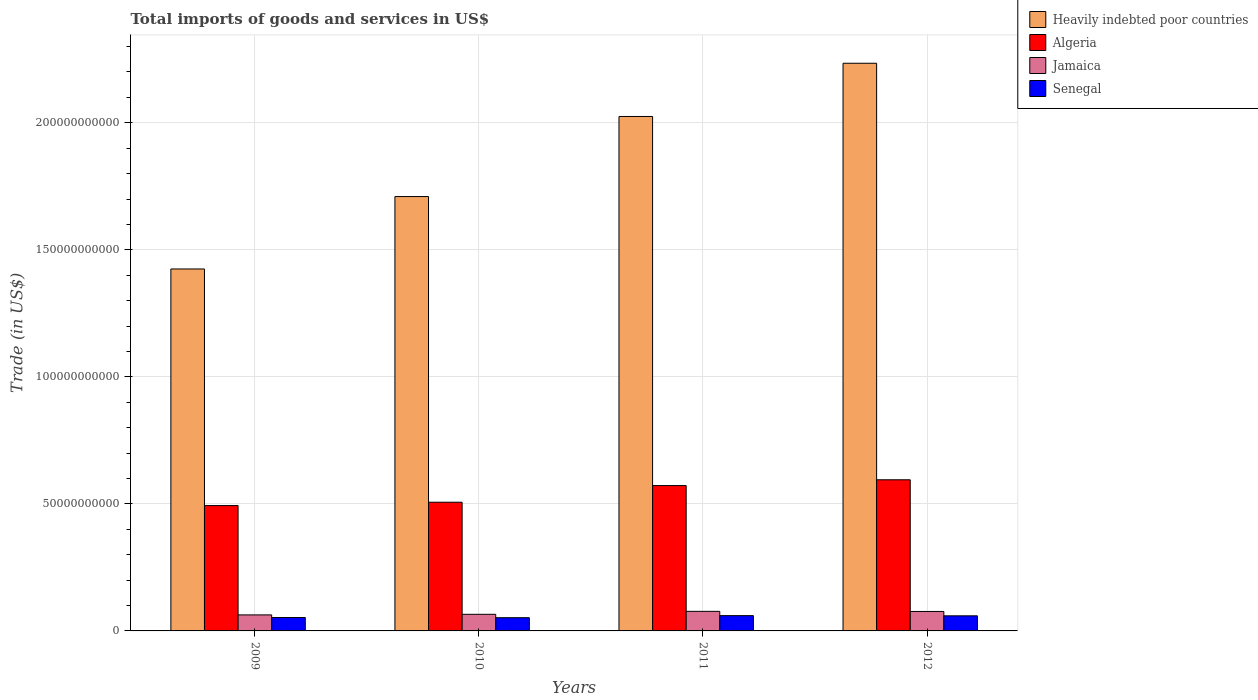How many different coloured bars are there?
Provide a succinct answer. 4. How many groups of bars are there?
Give a very brief answer. 4. Are the number of bars on each tick of the X-axis equal?
Ensure brevity in your answer.  Yes. How many bars are there on the 2nd tick from the right?
Provide a succinct answer. 4. What is the total imports of goods and services in Algeria in 2010?
Keep it short and to the point. 5.07e+1. Across all years, what is the maximum total imports of goods and services in Algeria?
Your response must be concise. 5.95e+1. Across all years, what is the minimum total imports of goods and services in Senegal?
Offer a terse response. 5.20e+09. In which year was the total imports of goods and services in Heavily indebted poor countries minimum?
Provide a short and direct response. 2009. What is the total total imports of goods and services in Jamaica in the graph?
Your answer should be very brief. 2.82e+1. What is the difference between the total imports of goods and services in Heavily indebted poor countries in 2009 and that in 2012?
Ensure brevity in your answer.  -8.10e+1. What is the difference between the total imports of goods and services in Heavily indebted poor countries in 2010 and the total imports of goods and services in Senegal in 2009?
Give a very brief answer. 1.66e+11. What is the average total imports of goods and services in Heavily indebted poor countries per year?
Provide a short and direct response. 1.85e+11. In the year 2010, what is the difference between the total imports of goods and services in Senegal and total imports of goods and services in Heavily indebted poor countries?
Keep it short and to the point. -1.66e+11. What is the ratio of the total imports of goods and services in Algeria in 2009 to that in 2010?
Provide a short and direct response. 0.97. Is the difference between the total imports of goods and services in Senegal in 2009 and 2012 greater than the difference between the total imports of goods and services in Heavily indebted poor countries in 2009 and 2012?
Keep it short and to the point. Yes. What is the difference between the highest and the second highest total imports of goods and services in Jamaica?
Provide a short and direct response. 4.67e+07. What is the difference between the highest and the lowest total imports of goods and services in Jamaica?
Offer a very short reply. 1.40e+09. In how many years, is the total imports of goods and services in Senegal greater than the average total imports of goods and services in Senegal taken over all years?
Your response must be concise. 2. Is the sum of the total imports of goods and services in Algeria in 2011 and 2012 greater than the maximum total imports of goods and services in Heavily indebted poor countries across all years?
Give a very brief answer. No. What does the 4th bar from the left in 2011 represents?
Your response must be concise. Senegal. What does the 4th bar from the right in 2011 represents?
Offer a very short reply. Heavily indebted poor countries. How many years are there in the graph?
Provide a succinct answer. 4. What is the difference between two consecutive major ticks on the Y-axis?
Make the answer very short. 5.00e+1. Are the values on the major ticks of Y-axis written in scientific E-notation?
Your answer should be very brief. No. What is the title of the graph?
Provide a short and direct response. Total imports of goods and services in US$. What is the label or title of the Y-axis?
Provide a short and direct response. Trade (in US$). What is the Trade (in US$) in Heavily indebted poor countries in 2009?
Keep it short and to the point. 1.42e+11. What is the Trade (in US$) in Algeria in 2009?
Keep it short and to the point. 4.93e+1. What is the Trade (in US$) of Jamaica in 2009?
Ensure brevity in your answer.  6.31e+09. What is the Trade (in US$) in Senegal in 2009?
Make the answer very short. 5.27e+09. What is the Trade (in US$) in Heavily indebted poor countries in 2010?
Provide a succinct answer. 1.71e+11. What is the Trade (in US$) in Algeria in 2010?
Keep it short and to the point. 5.07e+1. What is the Trade (in US$) in Jamaica in 2010?
Offer a very short reply. 6.54e+09. What is the Trade (in US$) in Senegal in 2010?
Give a very brief answer. 5.20e+09. What is the Trade (in US$) of Heavily indebted poor countries in 2011?
Provide a succinct answer. 2.02e+11. What is the Trade (in US$) in Algeria in 2011?
Your response must be concise. 5.72e+1. What is the Trade (in US$) of Jamaica in 2011?
Keep it short and to the point. 7.70e+09. What is the Trade (in US$) of Senegal in 2011?
Give a very brief answer. 6.02e+09. What is the Trade (in US$) in Heavily indebted poor countries in 2012?
Ensure brevity in your answer.  2.23e+11. What is the Trade (in US$) in Algeria in 2012?
Your answer should be very brief. 5.95e+1. What is the Trade (in US$) in Jamaica in 2012?
Make the answer very short. 7.66e+09. What is the Trade (in US$) in Senegal in 2012?
Your answer should be compact. 5.94e+09. Across all years, what is the maximum Trade (in US$) in Heavily indebted poor countries?
Provide a short and direct response. 2.23e+11. Across all years, what is the maximum Trade (in US$) in Algeria?
Provide a short and direct response. 5.95e+1. Across all years, what is the maximum Trade (in US$) of Jamaica?
Provide a short and direct response. 7.70e+09. Across all years, what is the maximum Trade (in US$) in Senegal?
Provide a short and direct response. 6.02e+09. Across all years, what is the minimum Trade (in US$) of Heavily indebted poor countries?
Ensure brevity in your answer.  1.42e+11. Across all years, what is the minimum Trade (in US$) of Algeria?
Provide a short and direct response. 4.93e+1. Across all years, what is the minimum Trade (in US$) of Jamaica?
Your response must be concise. 6.31e+09. Across all years, what is the minimum Trade (in US$) of Senegal?
Offer a terse response. 5.20e+09. What is the total Trade (in US$) of Heavily indebted poor countries in the graph?
Your answer should be compact. 7.39e+11. What is the total Trade (in US$) of Algeria in the graph?
Your answer should be compact. 2.17e+11. What is the total Trade (in US$) of Jamaica in the graph?
Ensure brevity in your answer.  2.82e+1. What is the total Trade (in US$) of Senegal in the graph?
Ensure brevity in your answer.  2.24e+1. What is the difference between the Trade (in US$) of Heavily indebted poor countries in 2009 and that in 2010?
Offer a very short reply. -2.85e+1. What is the difference between the Trade (in US$) in Algeria in 2009 and that in 2010?
Make the answer very short. -1.32e+09. What is the difference between the Trade (in US$) of Jamaica in 2009 and that in 2010?
Provide a succinct answer. -2.33e+08. What is the difference between the Trade (in US$) of Senegal in 2009 and that in 2010?
Ensure brevity in your answer.  6.93e+07. What is the difference between the Trade (in US$) in Heavily indebted poor countries in 2009 and that in 2011?
Your response must be concise. -6.00e+1. What is the difference between the Trade (in US$) of Algeria in 2009 and that in 2011?
Your response must be concise. -7.88e+09. What is the difference between the Trade (in US$) in Jamaica in 2009 and that in 2011?
Keep it short and to the point. -1.40e+09. What is the difference between the Trade (in US$) in Senegal in 2009 and that in 2011?
Keep it short and to the point. -7.46e+08. What is the difference between the Trade (in US$) in Heavily indebted poor countries in 2009 and that in 2012?
Provide a short and direct response. -8.10e+1. What is the difference between the Trade (in US$) of Algeria in 2009 and that in 2012?
Make the answer very short. -1.02e+1. What is the difference between the Trade (in US$) of Jamaica in 2009 and that in 2012?
Ensure brevity in your answer.  -1.35e+09. What is the difference between the Trade (in US$) of Senegal in 2009 and that in 2012?
Keep it short and to the point. -6.71e+08. What is the difference between the Trade (in US$) of Heavily indebted poor countries in 2010 and that in 2011?
Your answer should be compact. -3.15e+1. What is the difference between the Trade (in US$) in Algeria in 2010 and that in 2011?
Provide a succinct answer. -6.56e+09. What is the difference between the Trade (in US$) in Jamaica in 2010 and that in 2011?
Your response must be concise. -1.16e+09. What is the difference between the Trade (in US$) of Senegal in 2010 and that in 2011?
Your response must be concise. -8.15e+08. What is the difference between the Trade (in US$) in Heavily indebted poor countries in 2010 and that in 2012?
Keep it short and to the point. -5.25e+1. What is the difference between the Trade (in US$) in Algeria in 2010 and that in 2012?
Ensure brevity in your answer.  -8.83e+09. What is the difference between the Trade (in US$) in Jamaica in 2010 and that in 2012?
Provide a short and direct response. -1.12e+09. What is the difference between the Trade (in US$) in Senegal in 2010 and that in 2012?
Your answer should be compact. -7.40e+08. What is the difference between the Trade (in US$) of Heavily indebted poor countries in 2011 and that in 2012?
Provide a short and direct response. -2.09e+1. What is the difference between the Trade (in US$) in Algeria in 2011 and that in 2012?
Provide a succinct answer. -2.27e+09. What is the difference between the Trade (in US$) of Jamaica in 2011 and that in 2012?
Give a very brief answer. 4.67e+07. What is the difference between the Trade (in US$) of Senegal in 2011 and that in 2012?
Your answer should be very brief. 7.49e+07. What is the difference between the Trade (in US$) of Heavily indebted poor countries in 2009 and the Trade (in US$) of Algeria in 2010?
Your answer should be compact. 9.18e+1. What is the difference between the Trade (in US$) in Heavily indebted poor countries in 2009 and the Trade (in US$) in Jamaica in 2010?
Provide a succinct answer. 1.36e+11. What is the difference between the Trade (in US$) of Heavily indebted poor countries in 2009 and the Trade (in US$) of Senegal in 2010?
Provide a short and direct response. 1.37e+11. What is the difference between the Trade (in US$) in Algeria in 2009 and the Trade (in US$) in Jamaica in 2010?
Keep it short and to the point. 4.28e+1. What is the difference between the Trade (in US$) of Algeria in 2009 and the Trade (in US$) of Senegal in 2010?
Offer a very short reply. 4.41e+1. What is the difference between the Trade (in US$) of Jamaica in 2009 and the Trade (in US$) of Senegal in 2010?
Offer a very short reply. 1.10e+09. What is the difference between the Trade (in US$) of Heavily indebted poor countries in 2009 and the Trade (in US$) of Algeria in 2011?
Provide a succinct answer. 8.52e+1. What is the difference between the Trade (in US$) in Heavily indebted poor countries in 2009 and the Trade (in US$) in Jamaica in 2011?
Your answer should be very brief. 1.35e+11. What is the difference between the Trade (in US$) in Heavily indebted poor countries in 2009 and the Trade (in US$) in Senegal in 2011?
Make the answer very short. 1.36e+11. What is the difference between the Trade (in US$) in Algeria in 2009 and the Trade (in US$) in Jamaica in 2011?
Offer a terse response. 4.16e+1. What is the difference between the Trade (in US$) in Algeria in 2009 and the Trade (in US$) in Senegal in 2011?
Keep it short and to the point. 4.33e+1. What is the difference between the Trade (in US$) in Jamaica in 2009 and the Trade (in US$) in Senegal in 2011?
Provide a short and direct response. 2.89e+08. What is the difference between the Trade (in US$) of Heavily indebted poor countries in 2009 and the Trade (in US$) of Algeria in 2012?
Make the answer very short. 8.30e+1. What is the difference between the Trade (in US$) of Heavily indebted poor countries in 2009 and the Trade (in US$) of Jamaica in 2012?
Offer a very short reply. 1.35e+11. What is the difference between the Trade (in US$) in Heavily indebted poor countries in 2009 and the Trade (in US$) in Senegal in 2012?
Make the answer very short. 1.37e+11. What is the difference between the Trade (in US$) in Algeria in 2009 and the Trade (in US$) in Jamaica in 2012?
Keep it short and to the point. 4.17e+1. What is the difference between the Trade (in US$) in Algeria in 2009 and the Trade (in US$) in Senegal in 2012?
Offer a terse response. 4.34e+1. What is the difference between the Trade (in US$) of Jamaica in 2009 and the Trade (in US$) of Senegal in 2012?
Provide a succinct answer. 3.64e+08. What is the difference between the Trade (in US$) in Heavily indebted poor countries in 2010 and the Trade (in US$) in Algeria in 2011?
Your answer should be compact. 1.14e+11. What is the difference between the Trade (in US$) in Heavily indebted poor countries in 2010 and the Trade (in US$) in Jamaica in 2011?
Offer a terse response. 1.63e+11. What is the difference between the Trade (in US$) in Heavily indebted poor countries in 2010 and the Trade (in US$) in Senegal in 2011?
Keep it short and to the point. 1.65e+11. What is the difference between the Trade (in US$) of Algeria in 2010 and the Trade (in US$) of Jamaica in 2011?
Offer a very short reply. 4.30e+1. What is the difference between the Trade (in US$) in Algeria in 2010 and the Trade (in US$) in Senegal in 2011?
Give a very brief answer. 4.46e+1. What is the difference between the Trade (in US$) of Jamaica in 2010 and the Trade (in US$) of Senegal in 2011?
Your answer should be compact. 5.22e+08. What is the difference between the Trade (in US$) of Heavily indebted poor countries in 2010 and the Trade (in US$) of Algeria in 2012?
Offer a terse response. 1.11e+11. What is the difference between the Trade (in US$) in Heavily indebted poor countries in 2010 and the Trade (in US$) in Jamaica in 2012?
Give a very brief answer. 1.63e+11. What is the difference between the Trade (in US$) in Heavily indebted poor countries in 2010 and the Trade (in US$) in Senegal in 2012?
Offer a terse response. 1.65e+11. What is the difference between the Trade (in US$) in Algeria in 2010 and the Trade (in US$) in Jamaica in 2012?
Offer a very short reply. 4.30e+1. What is the difference between the Trade (in US$) in Algeria in 2010 and the Trade (in US$) in Senegal in 2012?
Provide a succinct answer. 4.47e+1. What is the difference between the Trade (in US$) of Jamaica in 2010 and the Trade (in US$) of Senegal in 2012?
Offer a very short reply. 5.97e+08. What is the difference between the Trade (in US$) of Heavily indebted poor countries in 2011 and the Trade (in US$) of Algeria in 2012?
Offer a very short reply. 1.43e+11. What is the difference between the Trade (in US$) in Heavily indebted poor countries in 2011 and the Trade (in US$) in Jamaica in 2012?
Provide a short and direct response. 1.95e+11. What is the difference between the Trade (in US$) in Heavily indebted poor countries in 2011 and the Trade (in US$) in Senegal in 2012?
Offer a very short reply. 1.97e+11. What is the difference between the Trade (in US$) in Algeria in 2011 and the Trade (in US$) in Jamaica in 2012?
Offer a terse response. 4.96e+1. What is the difference between the Trade (in US$) of Algeria in 2011 and the Trade (in US$) of Senegal in 2012?
Your answer should be very brief. 5.13e+1. What is the difference between the Trade (in US$) in Jamaica in 2011 and the Trade (in US$) in Senegal in 2012?
Provide a succinct answer. 1.76e+09. What is the average Trade (in US$) in Heavily indebted poor countries per year?
Offer a very short reply. 1.85e+11. What is the average Trade (in US$) in Algeria per year?
Your response must be concise. 5.42e+1. What is the average Trade (in US$) in Jamaica per year?
Keep it short and to the point. 7.05e+09. What is the average Trade (in US$) in Senegal per year?
Make the answer very short. 5.61e+09. In the year 2009, what is the difference between the Trade (in US$) in Heavily indebted poor countries and Trade (in US$) in Algeria?
Offer a terse response. 9.31e+1. In the year 2009, what is the difference between the Trade (in US$) of Heavily indebted poor countries and Trade (in US$) of Jamaica?
Your answer should be compact. 1.36e+11. In the year 2009, what is the difference between the Trade (in US$) in Heavily indebted poor countries and Trade (in US$) in Senegal?
Offer a terse response. 1.37e+11. In the year 2009, what is the difference between the Trade (in US$) in Algeria and Trade (in US$) in Jamaica?
Provide a short and direct response. 4.30e+1. In the year 2009, what is the difference between the Trade (in US$) in Algeria and Trade (in US$) in Senegal?
Your response must be concise. 4.41e+1. In the year 2009, what is the difference between the Trade (in US$) of Jamaica and Trade (in US$) of Senegal?
Your answer should be compact. 1.04e+09. In the year 2010, what is the difference between the Trade (in US$) of Heavily indebted poor countries and Trade (in US$) of Algeria?
Offer a very short reply. 1.20e+11. In the year 2010, what is the difference between the Trade (in US$) of Heavily indebted poor countries and Trade (in US$) of Jamaica?
Offer a very short reply. 1.64e+11. In the year 2010, what is the difference between the Trade (in US$) in Heavily indebted poor countries and Trade (in US$) in Senegal?
Give a very brief answer. 1.66e+11. In the year 2010, what is the difference between the Trade (in US$) in Algeria and Trade (in US$) in Jamaica?
Provide a short and direct response. 4.41e+1. In the year 2010, what is the difference between the Trade (in US$) in Algeria and Trade (in US$) in Senegal?
Provide a succinct answer. 4.55e+1. In the year 2010, what is the difference between the Trade (in US$) in Jamaica and Trade (in US$) in Senegal?
Offer a terse response. 1.34e+09. In the year 2011, what is the difference between the Trade (in US$) of Heavily indebted poor countries and Trade (in US$) of Algeria?
Give a very brief answer. 1.45e+11. In the year 2011, what is the difference between the Trade (in US$) of Heavily indebted poor countries and Trade (in US$) of Jamaica?
Keep it short and to the point. 1.95e+11. In the year 2011, what is the difference between the Trade (in US$) in Heavily indebted poor countries and Trade (in US$) in Senegal?
Your response must be concise. 1.96e+11. In the year 2011, what is the difference between the Trade (in US$) in Algeria and Trade (in US$) in Jamaica?
Offer a very short reply. 4.95e+1. In the year 2011, what is the difference between the Trade (in US$) in Algeria and Trade (in US$) in Senegal?
Make the answer very short. 5.12e+1. In the year 2011, what is the difference between the Trade (in US$) in Jamaica and Trade (in US$) in Senegal?
Provide a succinct answer. 1.68e+09. In the year 2012, what is the difference between the Trade (in US$) in Heavily indebted poor countries and Trade (in US$) in Algeria?
Your response must be concise. 1.64e+11. In the year 2012, what is the difference between the Trade (in US$) in Heavily indebted poor countries and Trade (in US$) in Jamaica?
Make the answer very short. 2.16e+11. In the year 2012, what is the difference between the Trade (in US$) in Heavily indebted poor countries and Trade (in US$) in Senegal?
Offer a terse response. 2.17e+11. In the year 2012, what is the difference between the Trade (in US$) in Algeria and Trade (in US$) in Jamaica?
Provide a short and direct response. 5.18e+1. In the year 2012, what is the difference between the Trade (in US$) of Algeria and Trade (in US$) of Senegal?
Keep it short and to the point. 5.35e+1. In the year 2012, what is the difference between the Trade (in US$) in Jamaica and Trade (in US$) in Senegal?
Give a very brief answer. 1.71e+09. What is the ratio of the Trade (in US$) of Heavily indebted poor countries in 2009 to that in 2010?
Make the answer very short. 0.83. What is the ratio of the Trade (in US$) of Algeria in 2009 to that in 2010?
Your answer should be very brief. 0.97. What is the ratio of the Trade (in US$) in Jamaica in 2009 to that in 2010?
Offer a terse response. 0.96. What is the ratio of the Trade (in US$) in Senegal in 2009 to that in 2010?
Your answer should be compact. 1.01. What is the ratio of the Trade (in US$) in Heavily indebted poor countries in 2009 to that in 2011?
Your answer should be very brief. 0.7. What is the ratio of the Trade (in US$) in Algeria in 2009 to that in 2011?
Your response must be concise. 0.86. What is the ratio of the Trade (in US$) in Jamaica in 2009 to that in 2011?
Offer a very short reply. 0.82. What is the ratio of the Trade (in US$) in Senegal in 2009 to that in 2011?
Your answer should be compact. 0.88. What is the ratio of the Trade (in US$) in Heavily indebted poor countries in 2009 to that in 2012?
Ensure brevity in your answer.  0.64. What is the ratio of the Trade (in US$) in Algeria in 2009 to that in 2012?
Offer a very short reply. 0.83. What is the ratio of the Trade (in US$) of Jamaica in 2009 to that in 2012?
Give a very brief answer. 0.82. What is the ratio of the Trade (in US$) of Senegal in 2009 to that in 2012?
Your response must be concise. 0.89. What is the ratio of the Trade (in US$) of Heavily indebted poor countries in 2010 to that in 2011?
Keep it short and to the point. 0.84. What is the ratio of the Trade (in US$) of Algeria in 2010 to that in 2011?
Give a very brief answer. 0.89. What is the ratio of the Trade (in US$) in Jamaica in 2010 to that in 2011?
Provide a succinct answer. 0.85. What is the ratio of the Trade (in US$) in Senegal in 2010 to that in 2011?
Provide a short and direct response. 0.86. What is the ratio of the Trade (in US$) in Heavily indebted poor countries in 2010 to that in 2012?
Give a very brief answer. 0.77. What is the ratio of the Trade (in US$) in Algeria in 2010 to that in 2012?
Offer a very short reply. 0.85. What is the ratio of the Trade (in US$) of Jamaica in 2010 to that in 2012?
Provide a short and direct response. 0.85. What is the ratio of the Trade (in US$) of Senegal in 2010 to that in 2012?
Offer a terse response. 0.88. What is the ratio of the Trade (in US$) in Heavily indebted poor countries in 2011 to that in 2012?
Your response must be concise. 0.91. What is the ratio of the Trade (in US$) in Algeria in 2011 to that in 2012?
Ensure brevity in your answer.  0.96. What is the ratio of the Trade (in US$) of Jamaica in 2011 to that in 2012?
Your answer should be compact. 1.01. What is the ratio of the Trade (in US$) of Senegal in 2011 to that in 2012?
Keep it short and to the point. 1.01. What is the difference between the highest and the second highest Trade (in US$) of Heavily indebted poor countries?
Your answer should be very brief. 2.09e+1. What is the difference between the highest and the second highest Trade (in US$) of Algeria?
Your answer should be very brief. 2.27e+09. What is the difference between the highest and the second highest Trade (in US$) in Jamaica?
Provide a succinct answer. 4.67e+07. What is the difference between the highest and the second highest Trade (in US$) of Senegal?
Give a very brief answer. 7.49e+07. What is the difference between the highest and the lowest Trade (in US$) of Heavily indebted poor countries?
Your answer should be compact. 8.10e+1. What is the difference between the highest and the lowest Trade (in US$) of Algeria?
Ensure brevity in your answer.  1.02e+1. What is the difference between the highest and the lowest Trade (in US$) of Jamaica?
Keep it short and to the point. 1.40e+09. What is the difference between the highest and the lowest Trade (in US$) of Senegal?
Your response must be concise. 8.15e+08. 